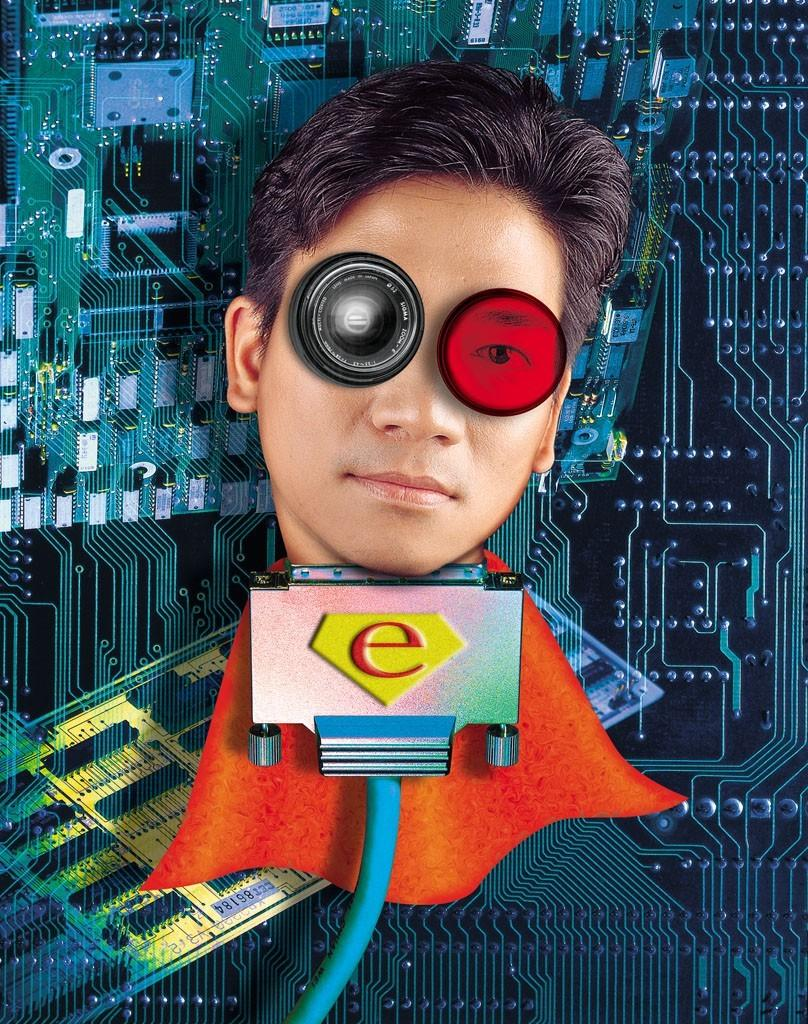What is the main subject of the image? The main subject of the image is a person's head. What is the person's head placed on? The person's head is on a chip. What colors are used for the chip? The chip is in blue and black colors. What else can be seen in the image besides the person's head and the chip? There is a blue color wire in the image. How is the wire connected in the image? The wire is connected to an object. What type of riddle can be solved by the person in the image? There is no riddle present in the image, nor is there any indication that the person is attempting to solve one. 